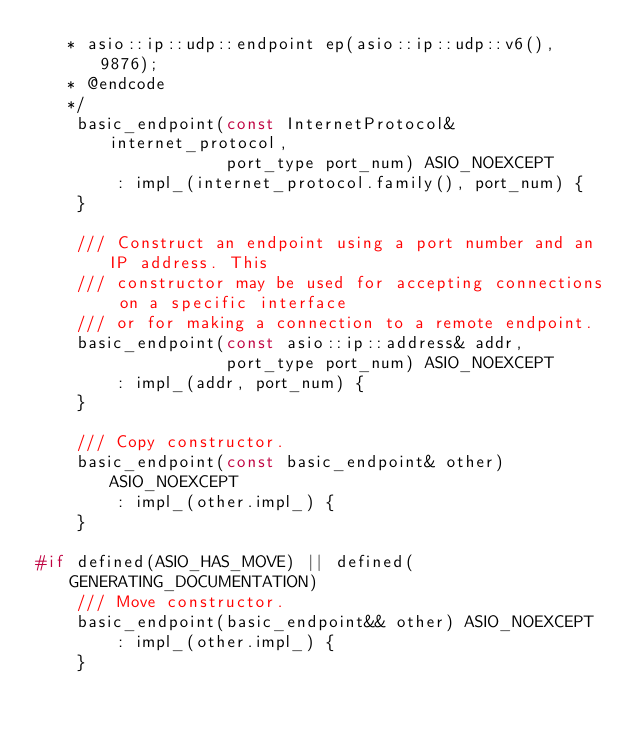Convert code to text. <code><loc_0><loc_0><loc_500><loc_500><_C++_>   * asio::ip::udp::endpoint ep(asio::ip::udp::v6(), 9876);
   * @endcode
   */
    basic_endpoint(const InternetProtocol& internet_protocol,
                   port_type port_num) ASIO_NOEXCEPT
        : impl_(internet_protocol.family(), port_num) {
    }

    /// Construct an endpoint using a port number and an IP address. This
    /// constructor may be used for accepting connections on a specific interface
    /// or for making a connection to a remote endpoint.
    basic_endpoint(const asio::ip::address& addr,
                   port_type port_num) ASIO_NOEXCEPT
        : impl_(addr, port_num) {
    }

    /// Copy constructor.
    basic_endpoint(const basic_endpoint& other) ASIO_NOEXCEPT
        : impl_(other.impl_) {
    }

#if defined(ASIO_HAS_MOVE) || defined(GENERATING_DOCUMENTATION)
    /// Move constructor.
    basic_endpoint(basic_endpoint&& other) ASIO_NOEXCEPT
        : impl_(other.impl_) {
    }</code> 